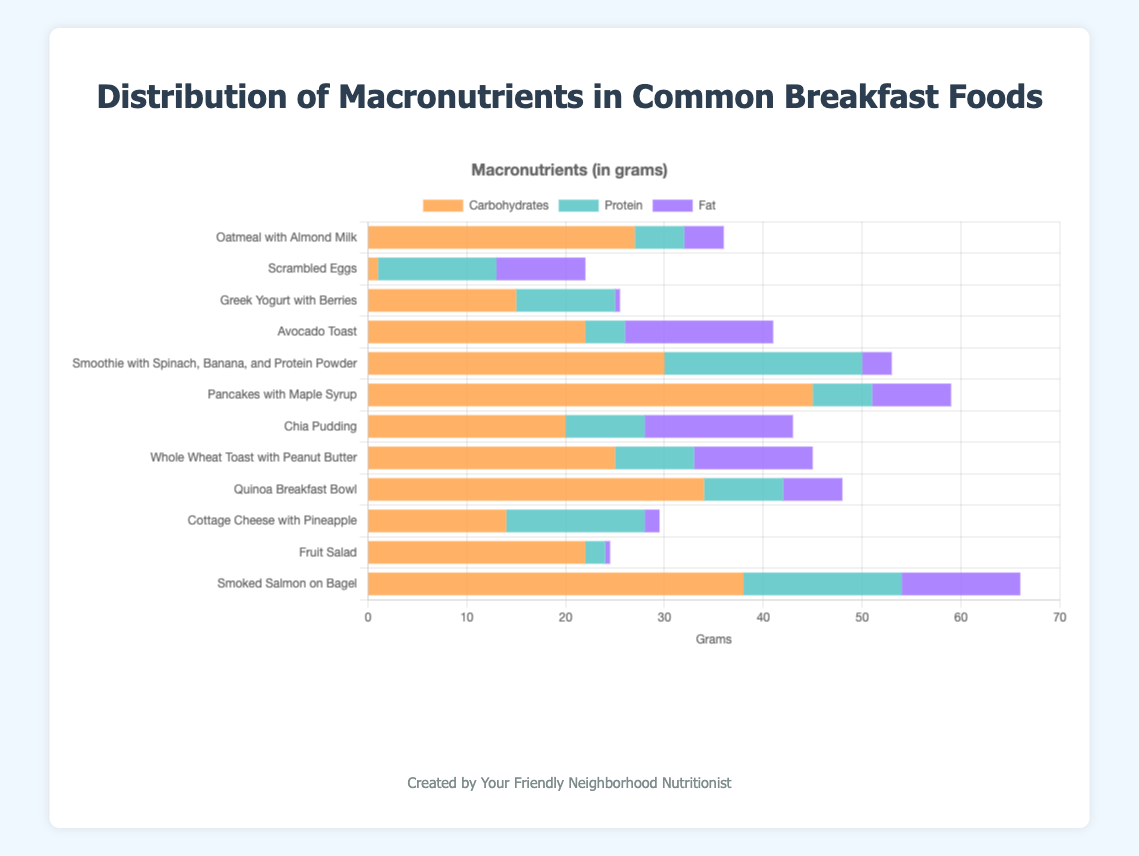Which breakfast food has the highest amount of carbohydrates? By looking at the 'Carbohydrates' section of the stacked bars, Pancakes with Maple Syrup stands out due to a longer segment of this color, representing 45 grams.
Answer: Pancakes with Maple Syrup Which breakfast food has the least amount of protein? By examining the 'Protein' sections, Fruit Salad has the shortest segment for protein, representing 2 grams.
Answer: Fruit Salad How does the fat content of Chia Pudding compare to that of Scrambled Eggs? The 'Fat' section for Chia Pudding and Scrambled Eggs can be compared visually. Both have fairly long segments, but Chia Pudding has 15 grams while Scrambled Eggs has 9 grams.
Answer: Chia Pudding has more fat Which food has the highest protein-to-carbohydrate ratio? Divide the protein by the carbohydrates for each food. The highest ratio comes from Scrambled Eggs (12/1 = 12).
Answer: Scrambled Eggs What is the total amount of fat in Oatmeal with Almond Milk and Whole Wheat Toast with Peanut Butter? Add the fat content of Oatmeal with Almond Milk (4 grams) and Whole Wheat Toast with Peanut Butter (12 grams).
Answer: 16 grams Which two foods have the closest total macronutrient amounts? Adding up carbohydrates, proteins, and fats for each food shows that Chia Pudding (20 + 8 + 15 = 43 grams) and Cottage Cheese with Pineapple (14 + 14 + 1.5 = 29.5 grams) are not close. Instead, Smoothie with Spinach, Banana, and Protein Powder (30 + 20 + 3 = 53 grams) and Pancakes with Maple Syrup (45 + 6 + 8 = 59 grams) are closer.
Answer: Smoothie and Pancakes What is the average carbohydrate content for all breakfast foods? Sum all carbohydrate values (27+1+15+22+30+45+20+25+34+14+22+38) = 293 grams, then divide by 12.
Answer: 24.42 grams Which breakfast food has almost equal amounts of carbohydrates and fats? Visually, Avocado Toast has close sections in carbs (22 grams) and fats (15 grams). Other foods do not have segments as close.
Answer: Avocado Toast What is the combined protein content for Greek Yogurt with Berries and Smoothie with Spinach, Banana, and Protein Powder? Sum the protein content of Greek Yogurt with Berries (10 grams) and Smoothie with Spinach, Banana, and Protein Powder (20 grams).
Answer: 30 grams Which breakfast food has the lowest percentage of its total weight as fats? Compare the fat-to-total ratios for each food. Greek Yogurt with Berries has 0.5 grams of fat out of 25.5 total grams, a very low percentage.
Answer: Greek Yogurt with Berries 